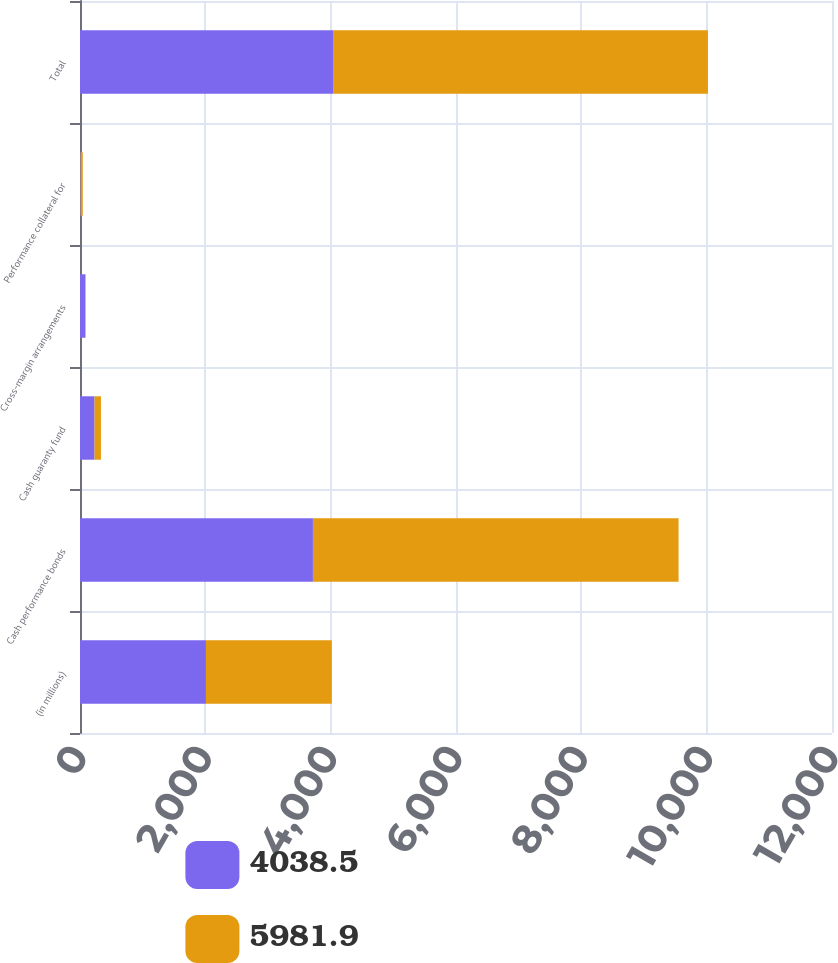<chart> <loc_0><loc_0><loc_500><loc_500><stacked_bar_chart><ecel><fcel>(in millions)<fcel>Cash performance bonds<fcel>Cash guaranty fund<fcel>Cross-margin arrangements<fcel>Performance collateral for<fcel>Total<nl><fcel>4038.5<fcel>2010<fcel>3717<fcel>231.8<fcel>79.7<fcel>10<fcel>4038.5<nl><fcel>5981.9<fcel>2009<fcel>5834.6<fcel>102.6<fcel>10.6<fcel>34.1<fcel>5981.9<nl></chart> 